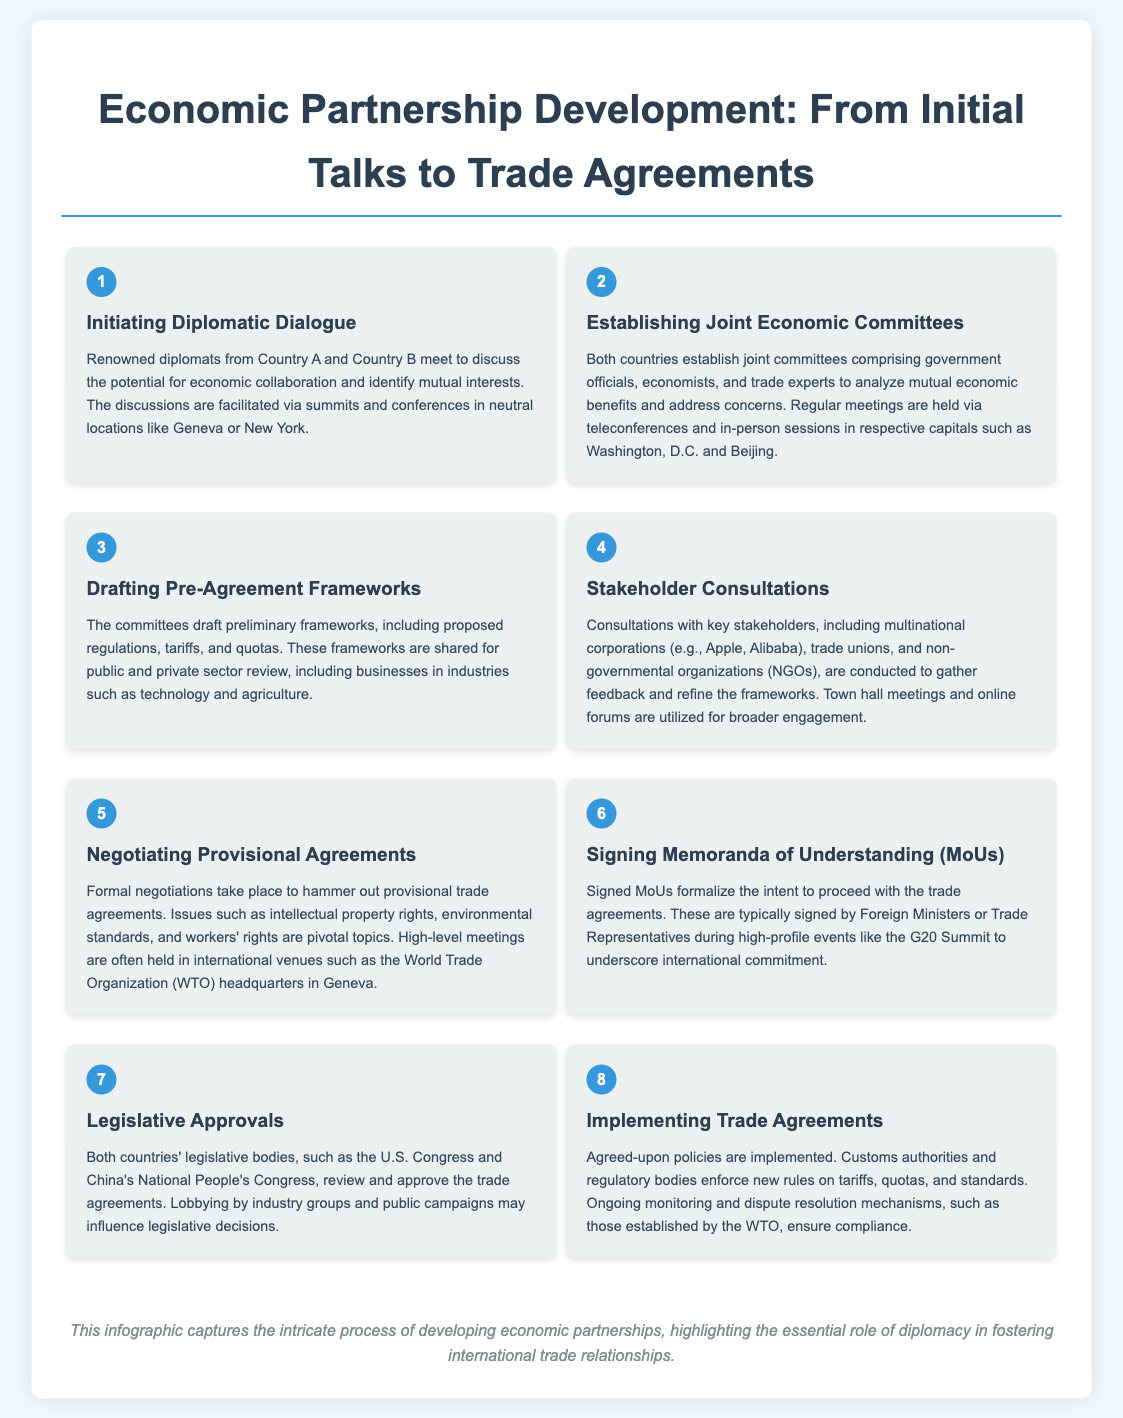What is the first step in the economic partnership development process? The first step is about initiating diplomatic dialogue where renowned diplomats from both countries meet.
Answer: Initiating Diplomatic Dialogue How many steps are outlined in the infographic? The infographic outlines a total of eight steps in the economic partnership development process.
Answer: 8 What is the purpose of establishing joint economic committees? The purpose is to analyze mutual economic benefits and address concerns with participation from government officials and trade experts.
Answer: Mutual economic benefits Which organizations are involved in the stakeholder consultations? Key stakeholders include multinational corporations, trade unions, and non-governmental organizations (NGOs).
Answer: Multinational corporations, trade unions, NGOs Where are high-level meetings for negotiating provisional agreements often held? High-level meetings for negotiating provisional agreements are often held at international venues such as the World Trade Organization (WTO) headquarters in Geneva.
Answer: WTO headquarters in Geneva What document formalizes the intent to proceed with trade agreements? The Memoranda of Understanding (MoUs) are signed to formalize the intent to proceed with trade agreements.
Answer: Memoranda of Understanding (MoUs) Which legislative bodies review and approve the trade agreements? The U.S. Congress and China's National People's Congress are the legislative bodies involved in reviewing and approving trade agreements.
Answer: U.S. Congress and China's National People's Congress What continuous action is taken to ensure compliance with trade agreements? Ongoing monitoring and dispute resolution mechanisms are established to ensure compliance with trade agreements.
Answer: Ongoing monitoring and dispute resolution mechanisms 